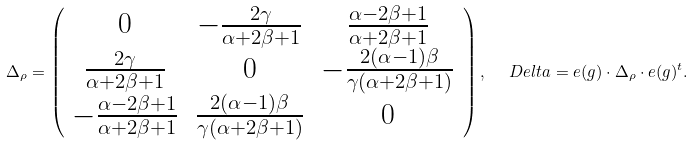<formula> <loc_0><loc_0><loc_500><loc_500>\Delta _ { \rho } = \left ( \begin{array} { c c c } 0 & - \frac { 2 \gamma } { \alpha + 2 \beta + 1 } & \frac { \alpha - 2 \beta + 1 } { \alpha + 2 \beta + 1 } \\ \frac { 2 \gamma } { \alpha + 2 \beta + 1 } & 0 & - \frac { 2 ( \alpha - 1 ) \beta } { \gamma ( \alpha + 2 \beta + 1 ) } \\ - \frac { \alpha - 2 \beta + 1 } { \alpha + 2 \beta + 1 } & \frac { 2 ( \alpha - 1 ) \beta } { \gamma ( \alpha + 2 \beta + 1 ) } & 0 \end{array} \right ) , \ \ \ D e l t a = e ( g ) \cdot \Delta _ { \rho } \cdot e ( g ) ^ { t } .</formula> 